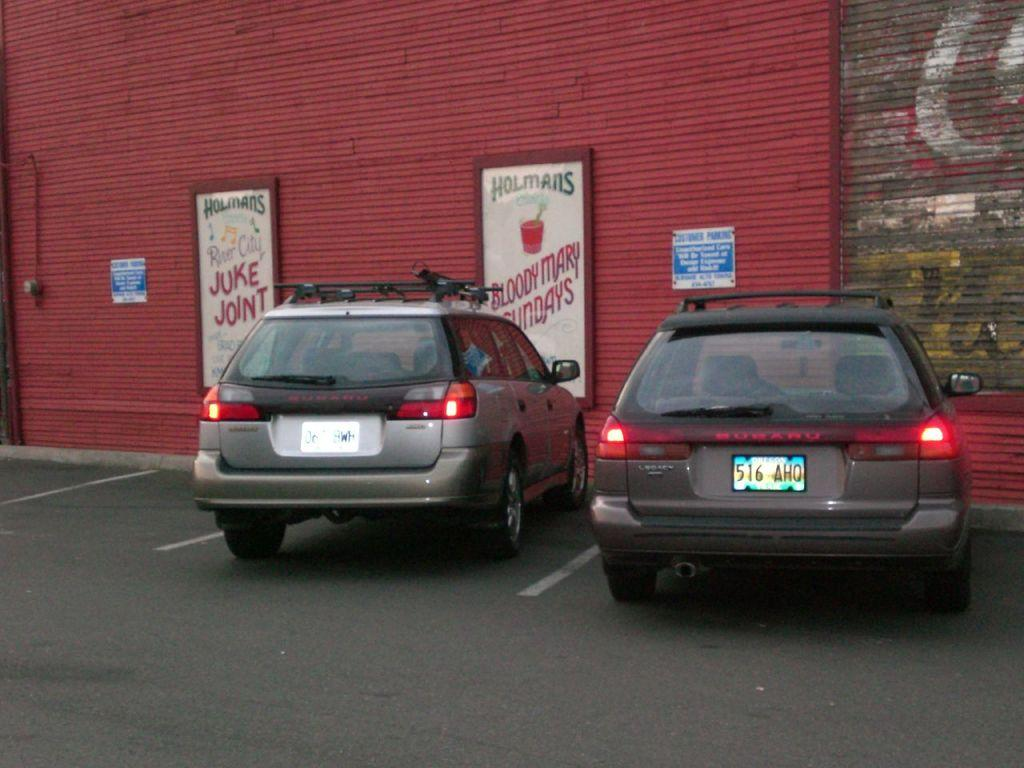<image>
Offer a succinct explanation of the picture presented. Two cars are parked next to a red building that has signs for Holmans. 